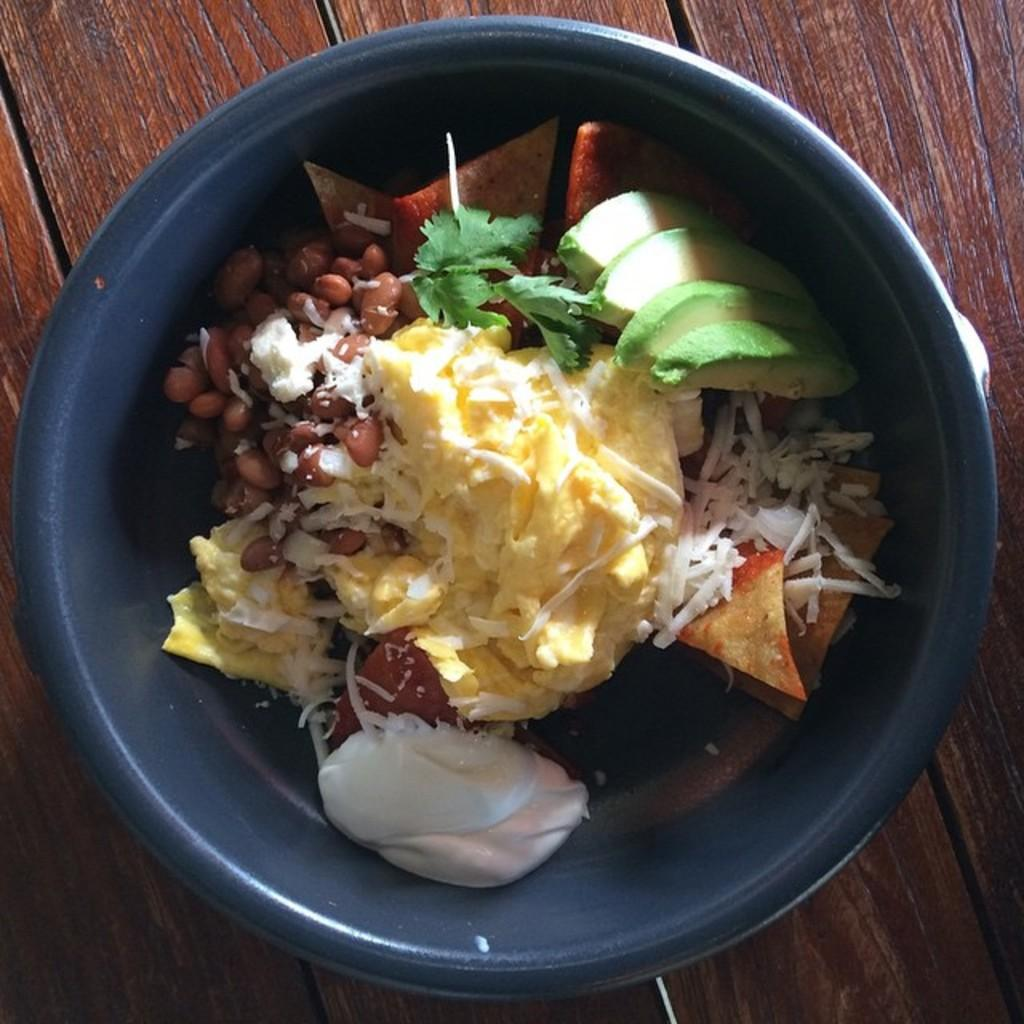What types of food items can be seen in the image? The food items in the image are in white, yellow, and green colors. What color is the bowl that contains the food items? The bowl is in a blue color. What is the color of the table on which the bowl is placed? The table is brown in color. How many people are in jail in the image? There is no reference to a jail or any people in the image; it features food items in a bowl on a table. 